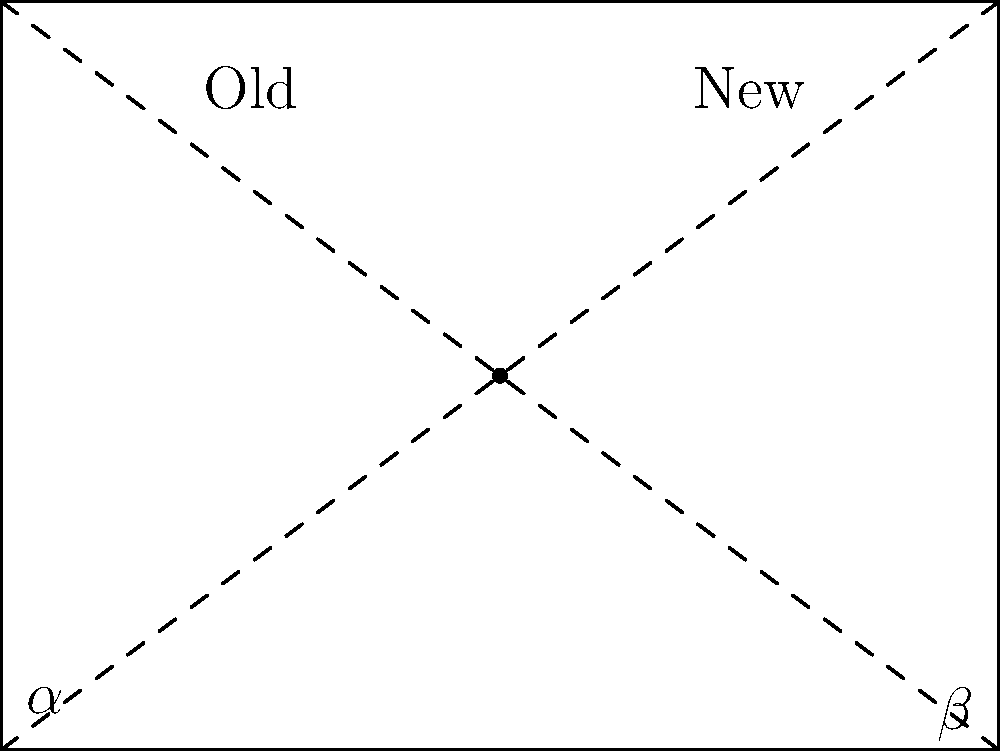In an urban redevelopment project, the intersection of old and new architectural styles creates interesting geometric patterns. The diagram shows a simplified representation of this intersection, where old structures form angle $\alpha$ and new structures form angle $\beta$ at their meeting point. If $\alpha = 65°$ and the sum of $\alpha$ and $\beta$ is $115°$, what is the measure of angle $\beta$? To solve this problem, we'll follow these steps:

1) We know that $\alpha = 65°$

2) We're told that the sum of $\alpha$ and $\beta$ is $115°$. We can express this as an equation:

   $\alpha + \beta = 115°$

3) Since we know the value of $\alpha$, we can substitute it into the equation:

   $65° + \beta = 115°$

4) To solve for $\beta$, we subtract $65°$ from both sides:

   $\beta = 115° - 65°$

5) Simplify:

   $\beta = 50°$

Therefore, the measure of angle $\beta$ is $50°$.
Answer: $50°$ 